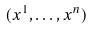Convert formula to latex. <formula><loc_0><loc_0><loc_500><loc_500>( x ^ { 1 } , \dots , x ^ { n } )</formula> 